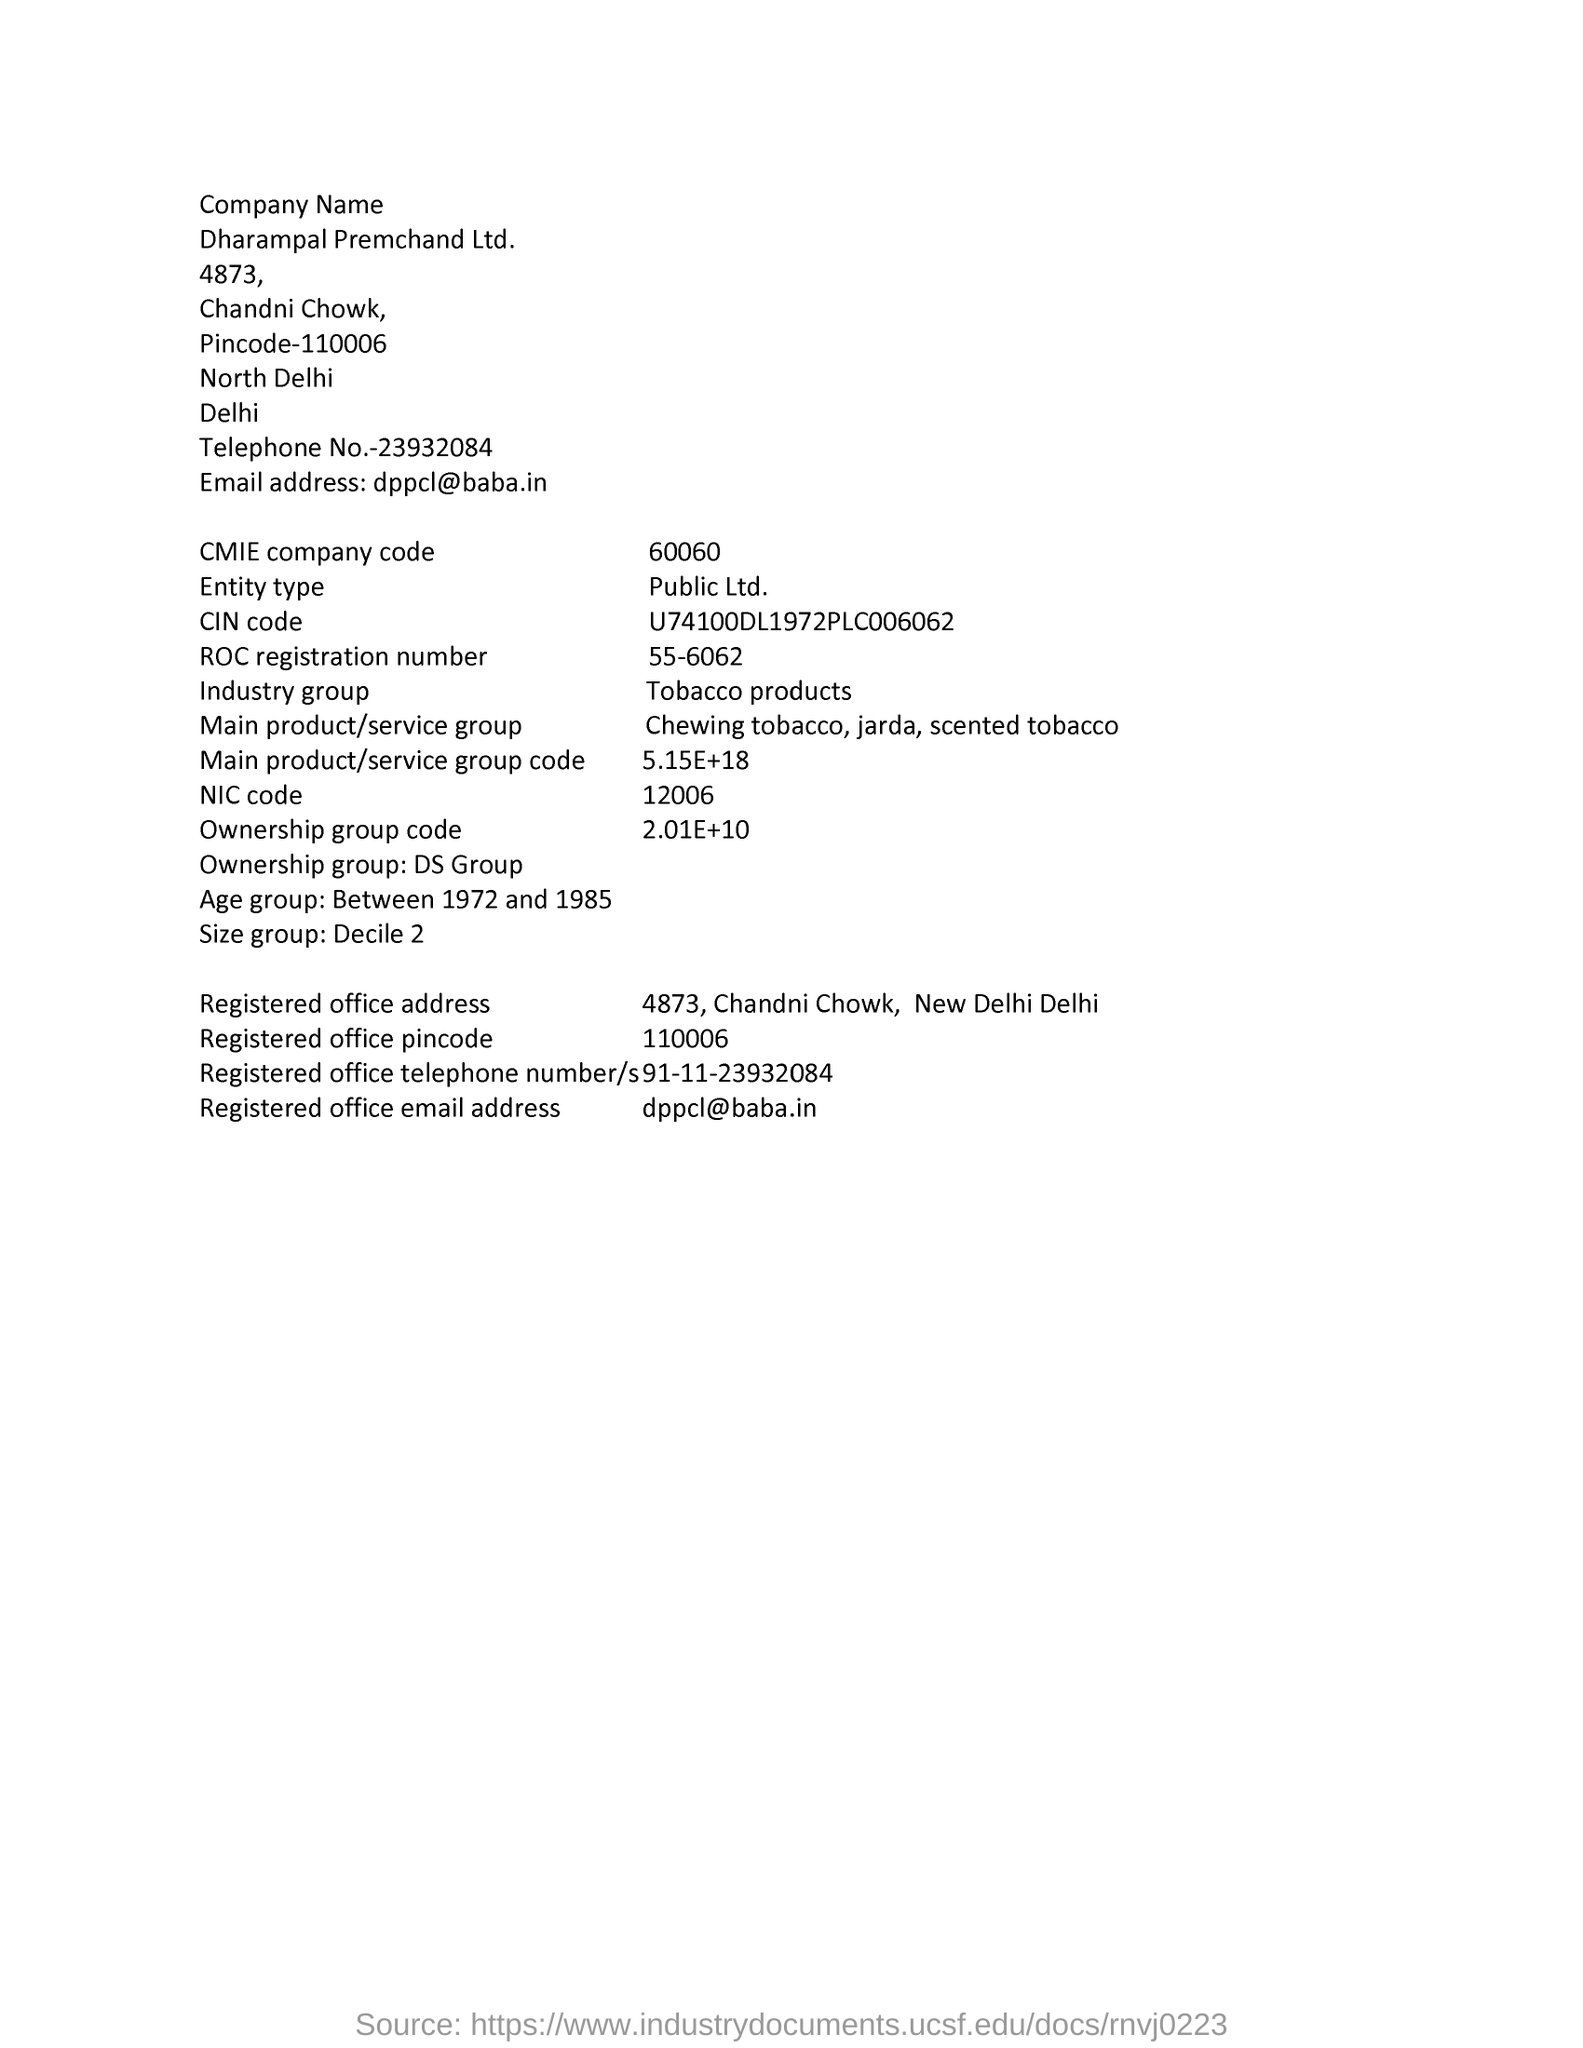What is industry group?
Keep it short and to the point. Tobacco products. What is CMIE code number?
Your answer should be very brief. 60060. What is entity type?
Keep it short and to the point. Public Ltd. What is NIC code?
Your response must be concise. 12006. 